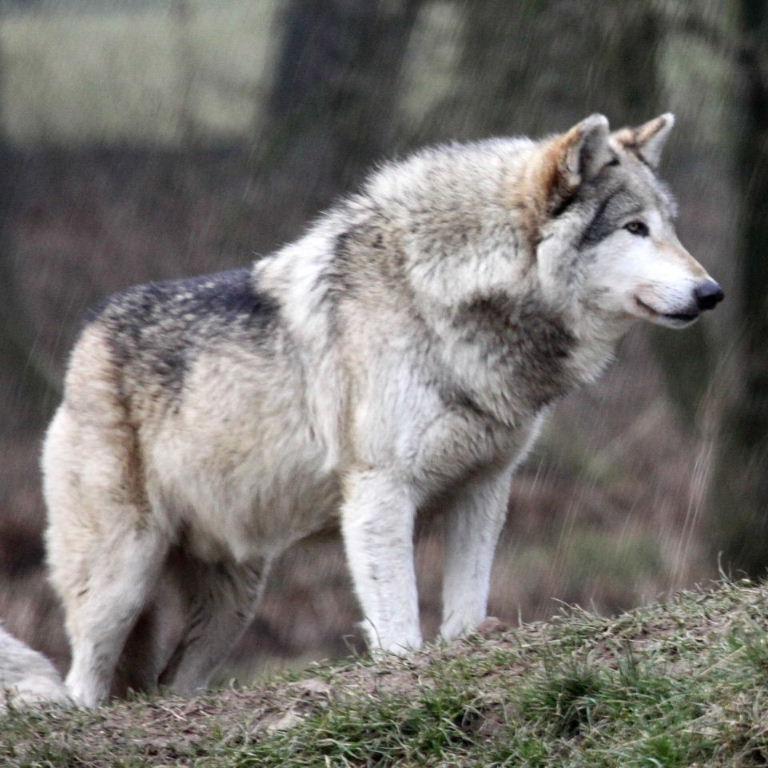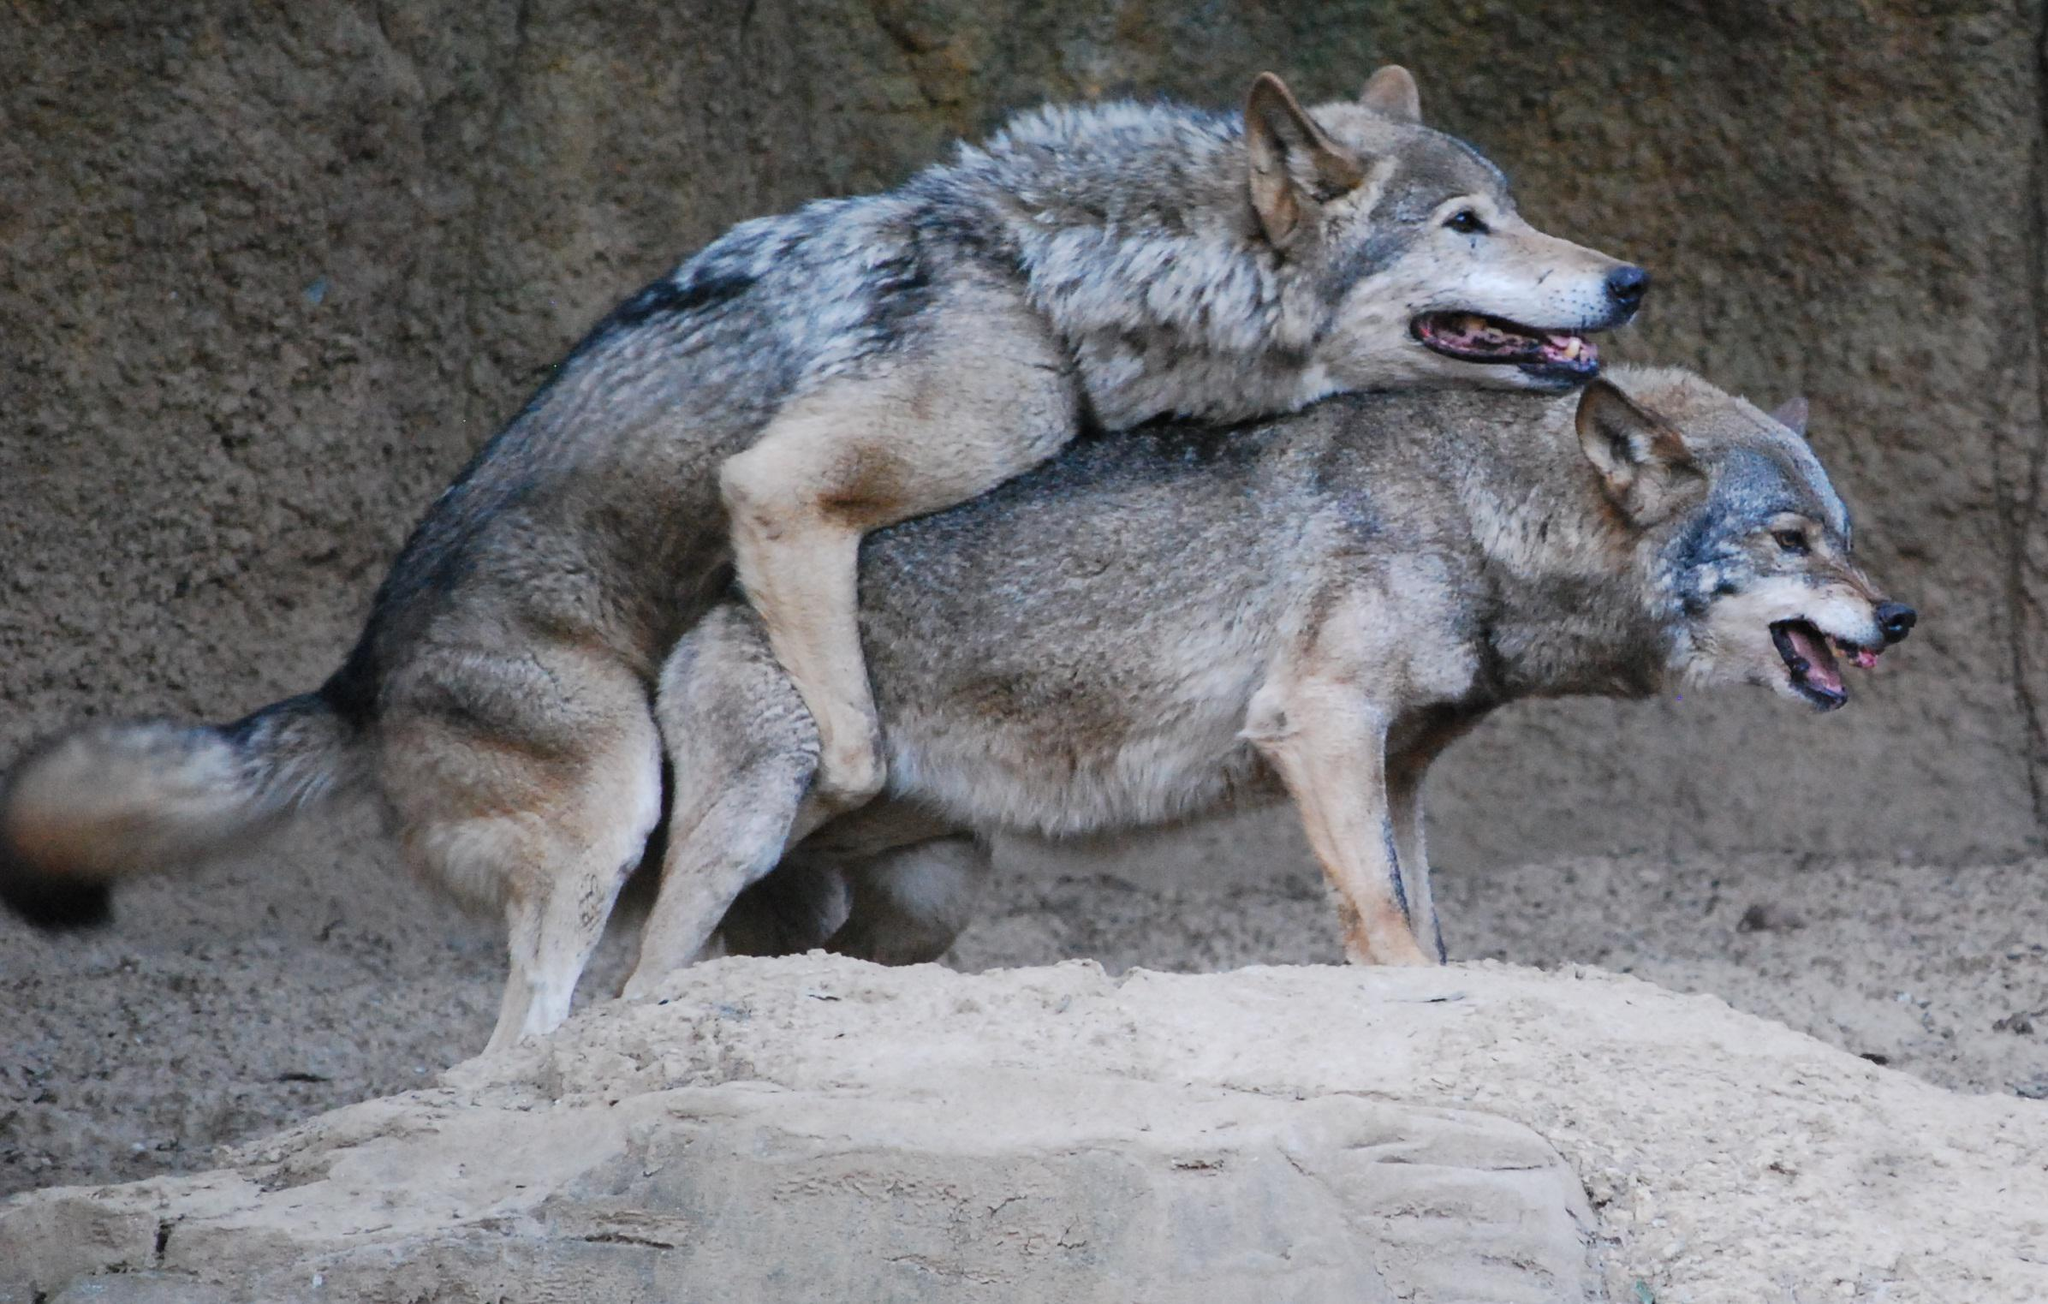The first image is the image on the left, the second image is the image on the right. Examine the images to the left and right. Is the description "One image contains more than one wolf, and one image contains a single wolf, who is standing on all fours." accurate? Answer yes or no. Yes. 